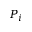<formula> <loc_0><loc_0><loc_500><loc_500>P _ { i }</formula> 